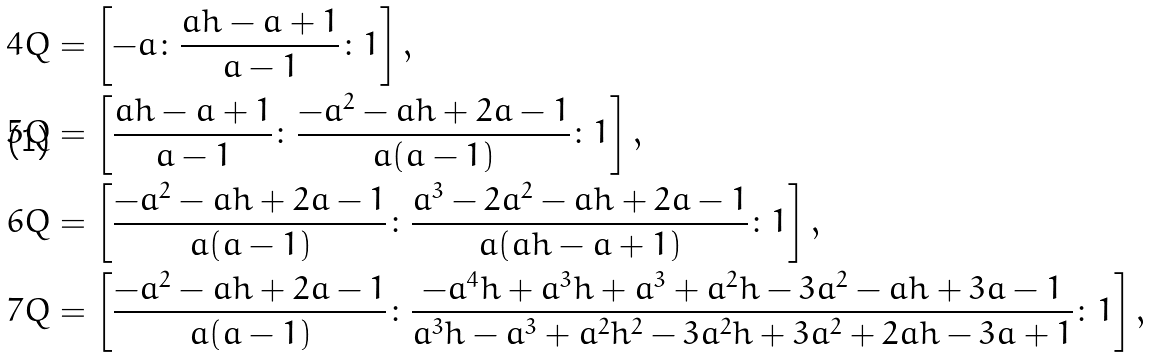<formula> <loc_0><loc_0><loc_500><loc_500>4 Q & = \left [ - a \colon \frac { a h - a + 1 } { a - 1 } \colon 1 \right ] , \\ 5 Q & = \left [ \frac { a h - a + 1 } { a - 1 } \colon \frac { - a ^ { 2 } - a h + 2 a - 1 } { a ( a - 1 ) } \colon 1 \right ] , \\ 6 Q & = \left [ \frac { - a ^ { 2 } - a h + 2 a - 1 } { a ( a - 1 ) } \colon \frac { a ^ { 3 } - 2 a ^ { 2 } - a h + 2 a - 1 } { a ( a h - a + 1 ) } \colon 1 \right ] , \\ 7 Q & = \left [ \frac { - a ^ { 2 } - a h + 2 a - 1 } { a ( a - 1 ) } \colon \frac { - a ^ { 4 } h + a ^ { 3 } h + a ^ { 3 } + a ^ { 2 } h - 3 a ^ { 2 } - a h + 3 a - 1 } { a ^ { 3 } h - a ^ { 3 } + a ^ { 2 } h ^ { 2 } - 3 a ^ { 2 } h + 3 a ^ { 2 } + 2 a h - 3 a + 1 } \colon 1 \right ] ,</formula> 